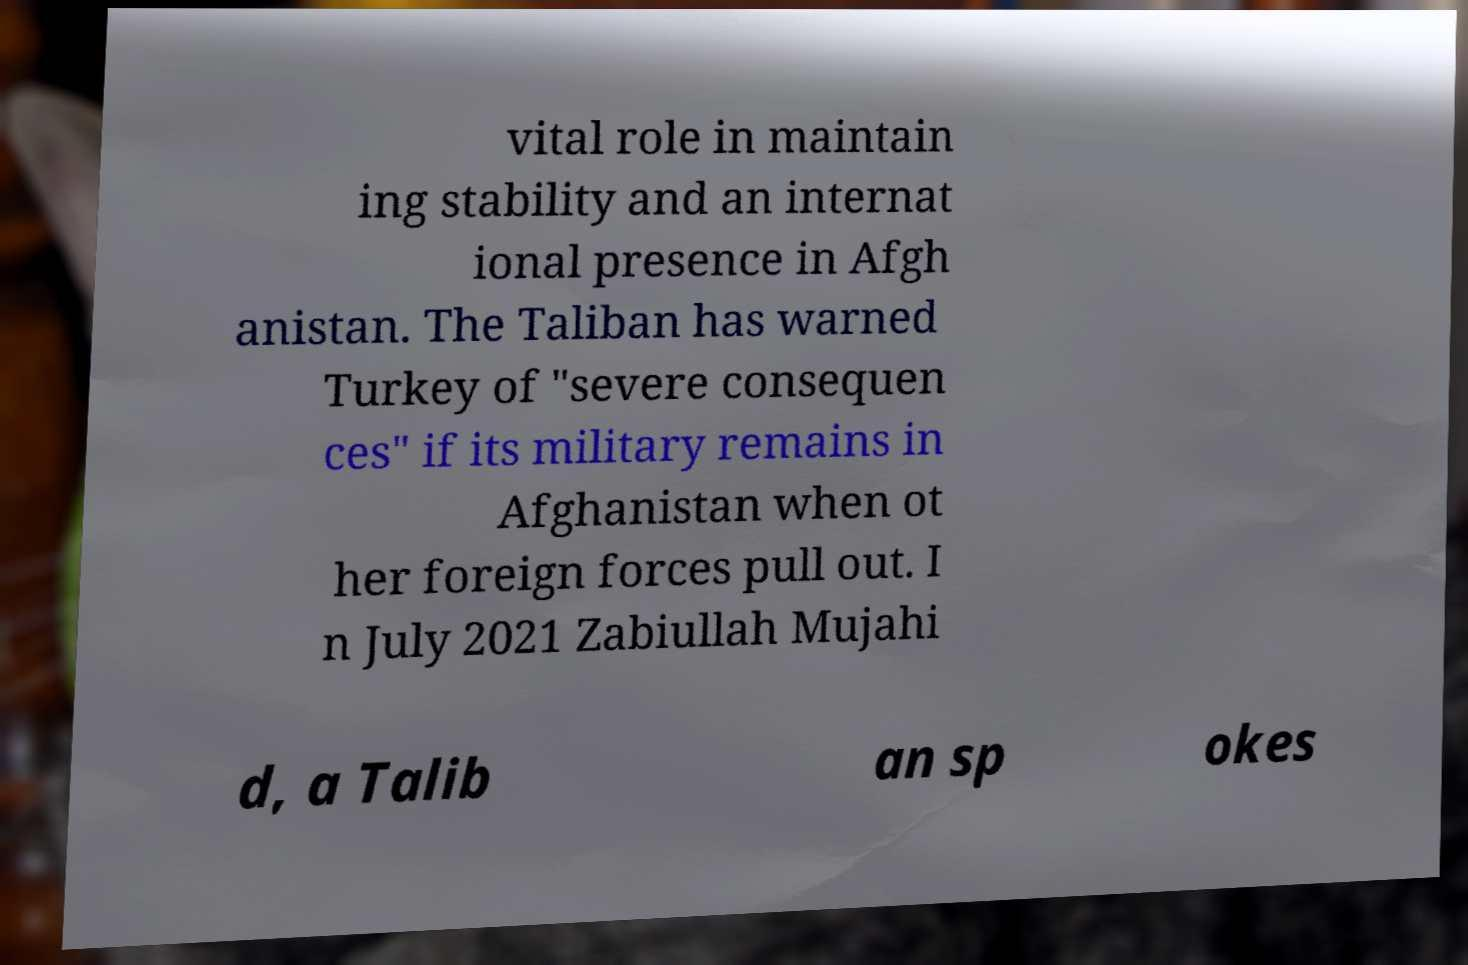Please read and relay the text visible in this image. What does it say? vital role in maintain ing stability and an internat ional presence in Afgh anistan. The Taliban has warned Turkey of "severe consequen ces" if its military remains in Afghanistan when ot her foreign forces pull out. I n July 2021 Zabiullah Mujahi d, a Talib an sp okes 